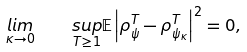Convert formula to latex. <formula><loc_0><loc_0><loc_500><loc_500>\underset { \kappa \rightarrow 0 } { l i m } \quad \underset { T \geq 1 } { s u p } \mathbb { E } \left | \rho _ { \psi } ^ { T } - \rho _ { \psi _ { \kappa } } ^ { T } \right | ^ { 2 } = 0 ,</formula> 